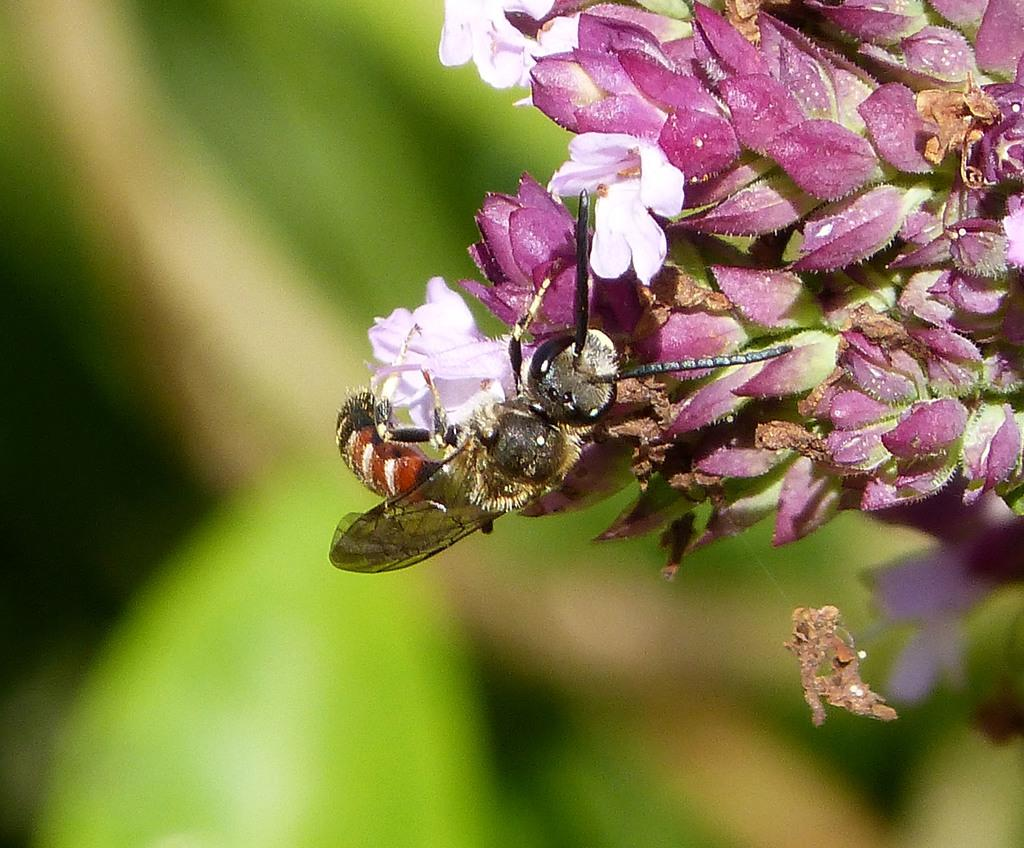What type of creature is in the image? There is an insect in the image. Can you describe the colors of the insect? The insect has orange, white, black, and brown colors. Where is the insect located in the image? The insect is on a flower. What color is the flower? The flower is pink in color. How would you describe the background of the image? The background of the image is green and black, with a blurry appearance. What type of treatment is the insect receiving for its sneeze in the image? There is no indication in the image that the insect is sneezing or receiving any treatment. 